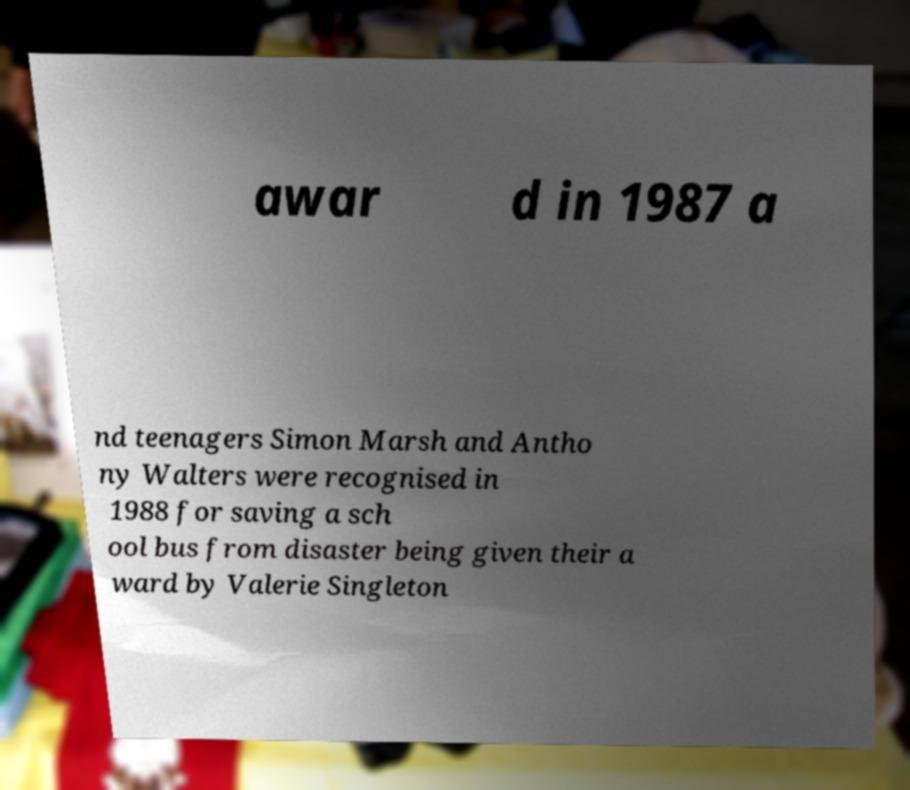Could you extract and type out the text from this image? awar d in 1987 a nd teenagers Simon Marsh and Antho ny Walters were recognised in 1988 for saving a sch ool bus from disaster being given their a ward by Valerie Singleton 